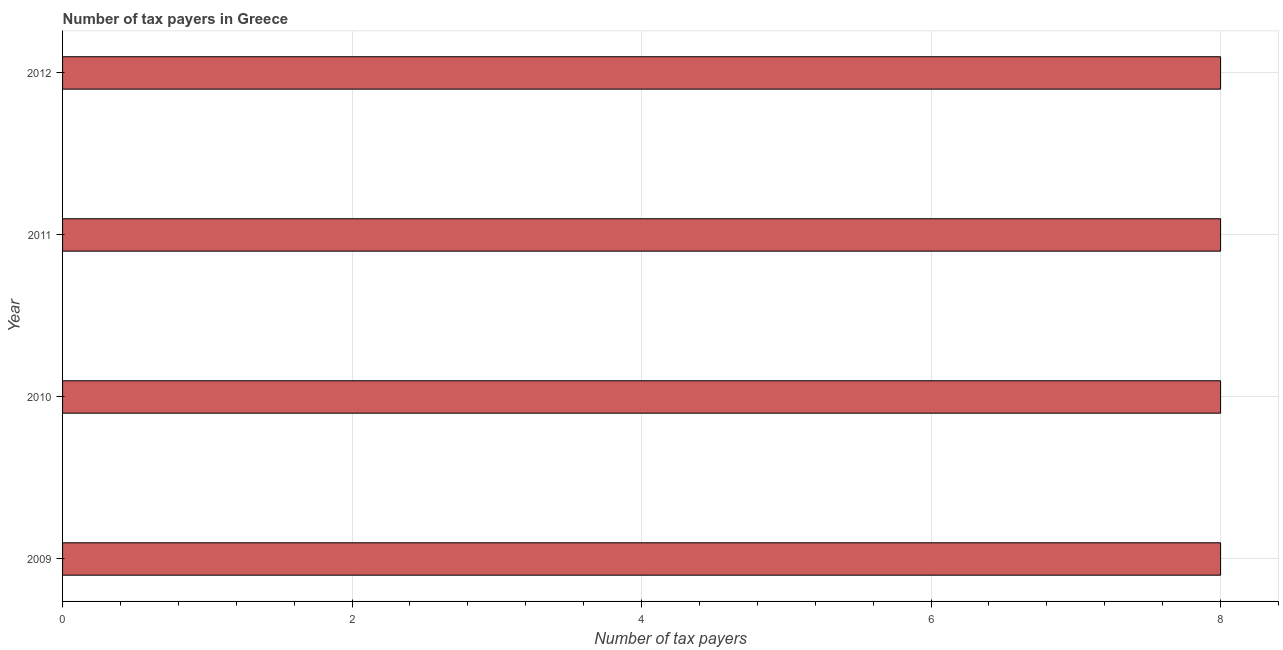Does the graph contain any zero values?
Offer a very short reply. No. Does the graph contain grids?
Keep it short and to the point. Yes. What is the title of the graph?
Ensure brevity in your answer.  Number of tax payers in Greece. What is the label or title of the X-axis?
Provide a short and direct response. Number of tax payers. What is the number of tax payers in 2012?
Your answer should be very brief. 8. Across all years, what is the maximum number of tax payers?
Provide a short and direct response. 8. What is the median number of tax payers?
Provide a succinct answer. 8. In how many years, is the number of tax payers greater than 5.2 ?
Provide a short and direct response. 4. In how many years, is the number of tax payers greater than the average number of tax payers taken over all years?
Your answer should be very brief. 0. Are all the bars in the graph horizontal?
Your answer should be very brief. Yes. What is the difference between two consecutive major ticks on the X-axis?
Your answer should be compact. 2. Are the values on the major ticks of X-axis written in scientific E-notation?
Your answer should be very brief. No. What is the Number of tax payers in 2010?
Your response must be concise. 8. What is the Number of tax payers in 2012?
Give a very brief answer. 8. What is the difference between the Number of tax payers in 2009 and 2010?
Make the answer very short. 0. What is the difference between the Number of tax payers in 2010 and 2011?
Your response must be concise. 0. What is the difference between the Number of tax payers in 2010 and 2012?
Make the answer very short. 0. What is the difference between the Number of tax payers in 2011 and 2012?
Provide a succinct answer. 0. What is the ratio of the Number of tax payers in 2009 to that in 2012?
Give a very brief answer. 1. What is the ratio of the Number of tax payers in 2010 to that in 2011?
Provide a succinct answer. 1. What is the ratio of the Number of tax payers in 2011 to that in 2012?
Give a very brief answer. 1. 